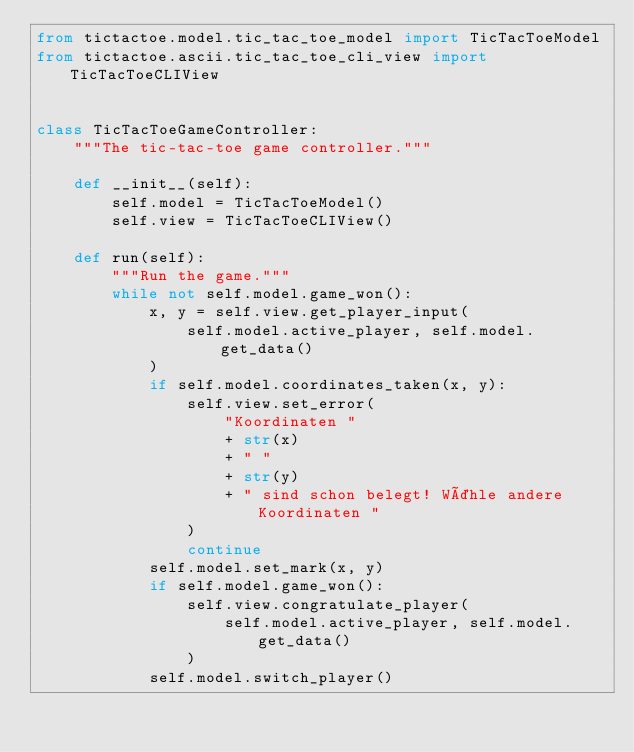Convert code to text. <code><loc_0><loc_0><loc_500><loc_500><_Python_>from tictactoe.model.tic_tac_toe_model import TicTacToeModel
from tictactoe.ascii.tic_tac_toe_cli_view import TicTacToeCLIView


class TicTacToeGameController:
    """The tic-tac-toe game controller."""

    def __init__(self):
        self.model = TicTacToeModel()
        self.view = TicTacToeCLIView()

    def run(self):
        """Run the game."""
        while not self.model.game_won():
            x, y = self.view.get_player_input(
                self.model.active_player, self.model.get_data()
            )
            if self.model.coordinates_taken(x, y):
                self.view.set_error(
                    "Koordinaten "
                    + str(x)
                    + " "
                    + str(y)
                    + " sind schon belegt! Wähle andere Koordinaten "
                )
                continue
            self.model.set_mark(x, y)
            if self.model.game_won():
                self.view.congratulate_player(
                    self.model.active_player, self.model.get_data()
                )
            self.model.switch_player()
</code> 